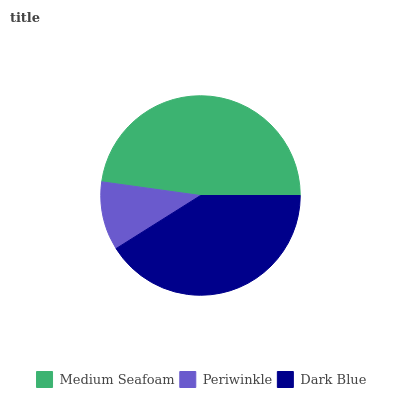Is Periwinkle the minimum?
Answer yes or no. Yes. Is Medium Seafoam the maximum?
Answer yes or no. Yes. Is Dark Blue the minimum?
Answer yes or no. No. Is Dark Blue the maximum?
Answer yes or no. No. Is Dark Blue greater than Periwinkle?
Answer yes or no. Yes. Is Periwinkle less than Dark Blue?
Answer yes or no. Yes. Is Periwinkle greater than Dark Blue?
Answer yes or no. No. Is Dark Blue less than Periwinkle?
Answer yes or no. No. Is Dark Blue the high median?
Answer yes or no. Yes. Is Dark Blue the low median?
Answer yes or no. Yes. Is Periwinkle the high median?
Answer yes or no. No. Is Periwinkle the low median?
Answer yes or no. No. 